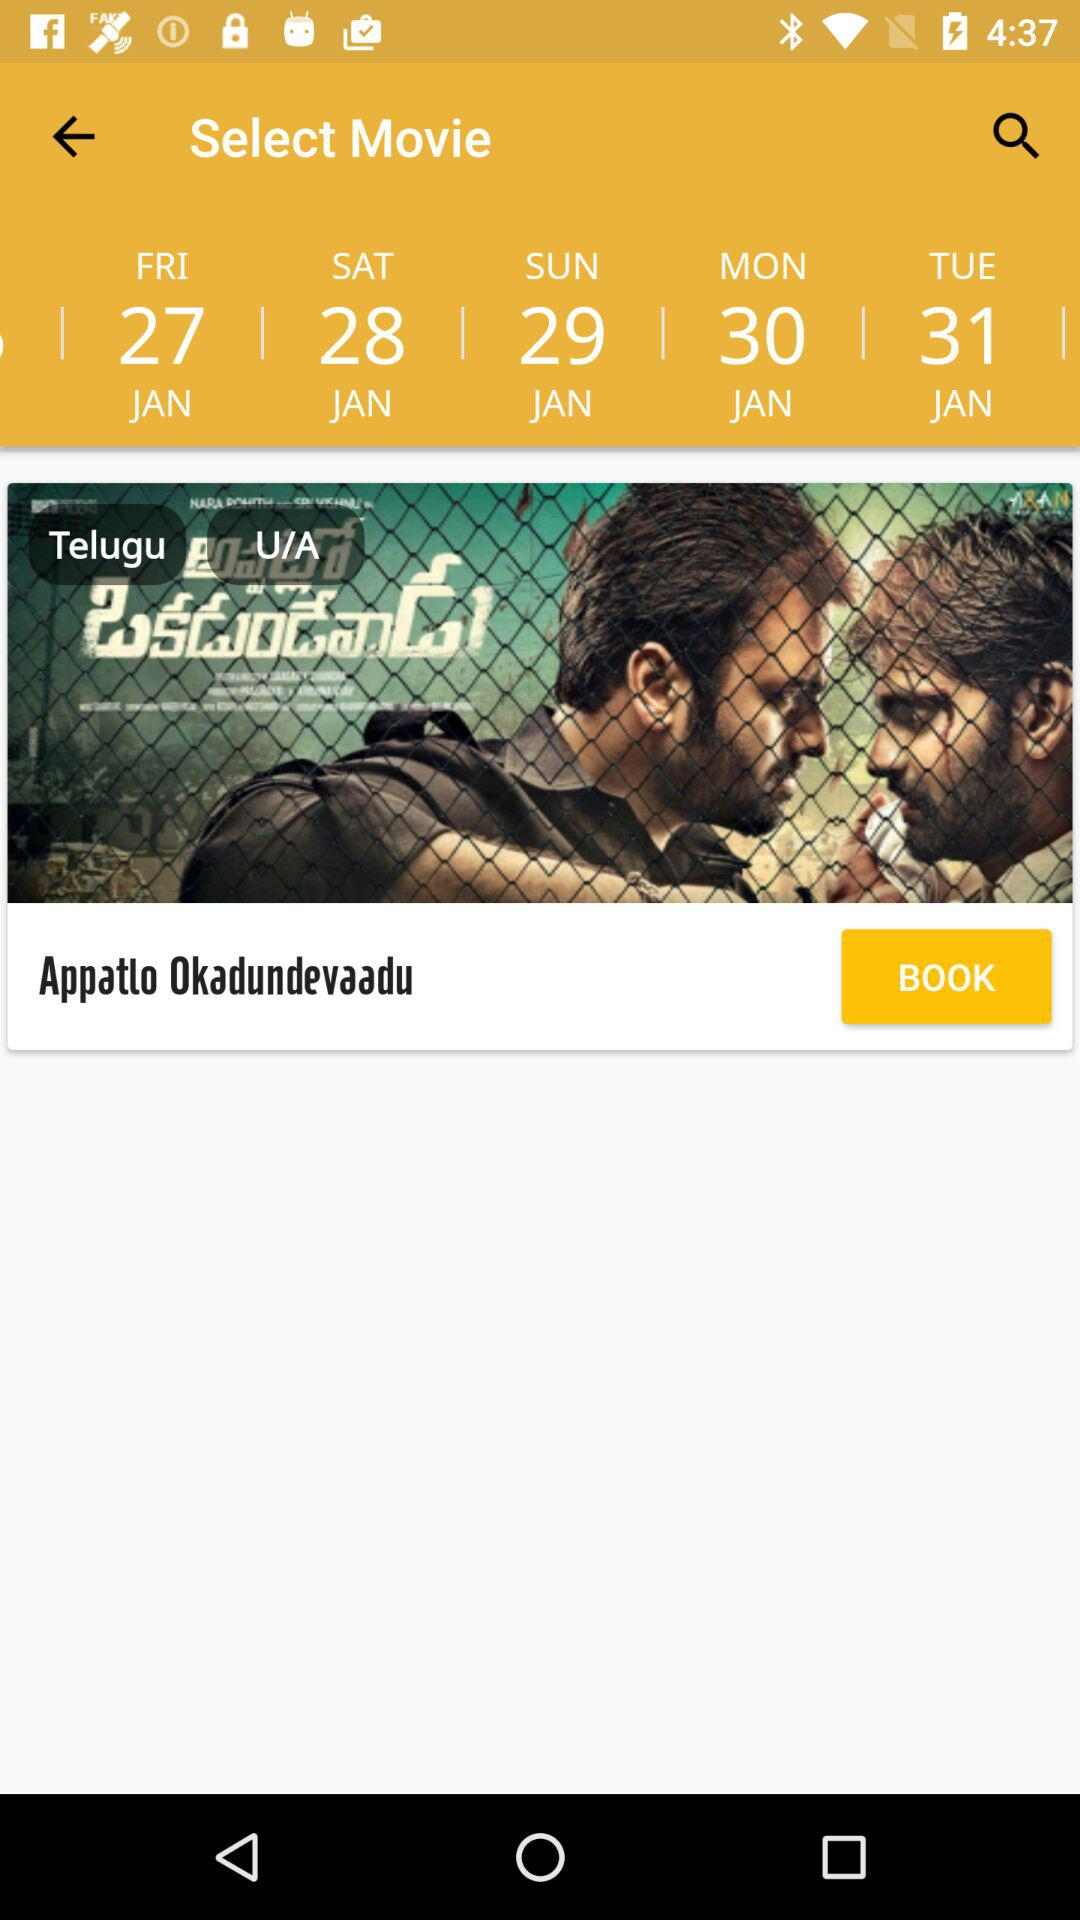What is the name of the movie?
Answer the question using a single word or phrase. Appatlo Okadundevaadu 